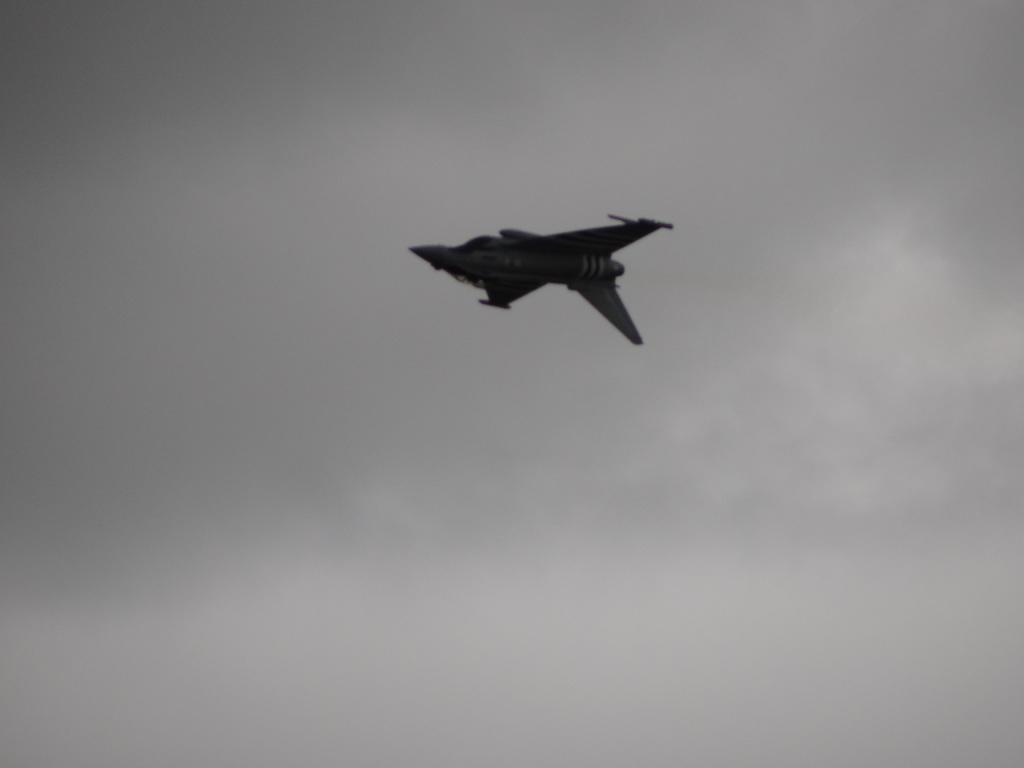What is the main subject of the image? The main subject of the image is an airplane. What is the airplane doing in the image? The airplane is flying in the image. What can be seen in the background of the image? The sky is visible in the background of the image. How many turkeys are sitting on the wings of the airplane in the image? There are no turkeys present in the image, and therefore no turkeys are sitting on the wings of the airplane. 